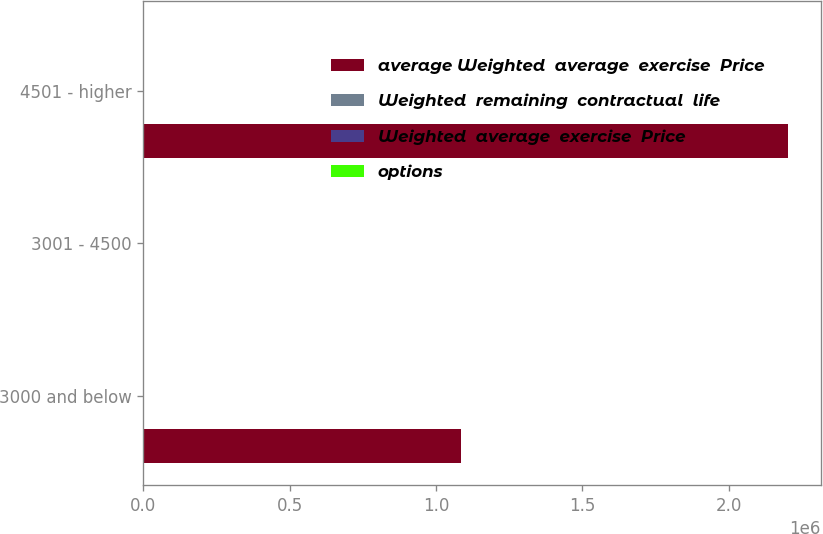Convert chart. <chart><loc_0><loc_0><loc_500><loc_500><stacked_bar_chart><ecel><fcel>3000 and below<fcel>3001 - 4500<fcel>4501 - higher<nl><fcel>average Weighted  average  exercise  Price<fcel>1.08648e+06<fcel>34<fcel>2.20332e+06<nl><fcel>Weighted  remaining  contractual  life<fcel>2.18<fcel>4.52<fcel>8.75<nl><fcel>Weighted  average  exercise  Price<fcel>23.69<fcel>34.5<fcel>50.49<nl><fcel>options<fcel>23.64<fcel>34<fcel>48.63<nl></chart> 